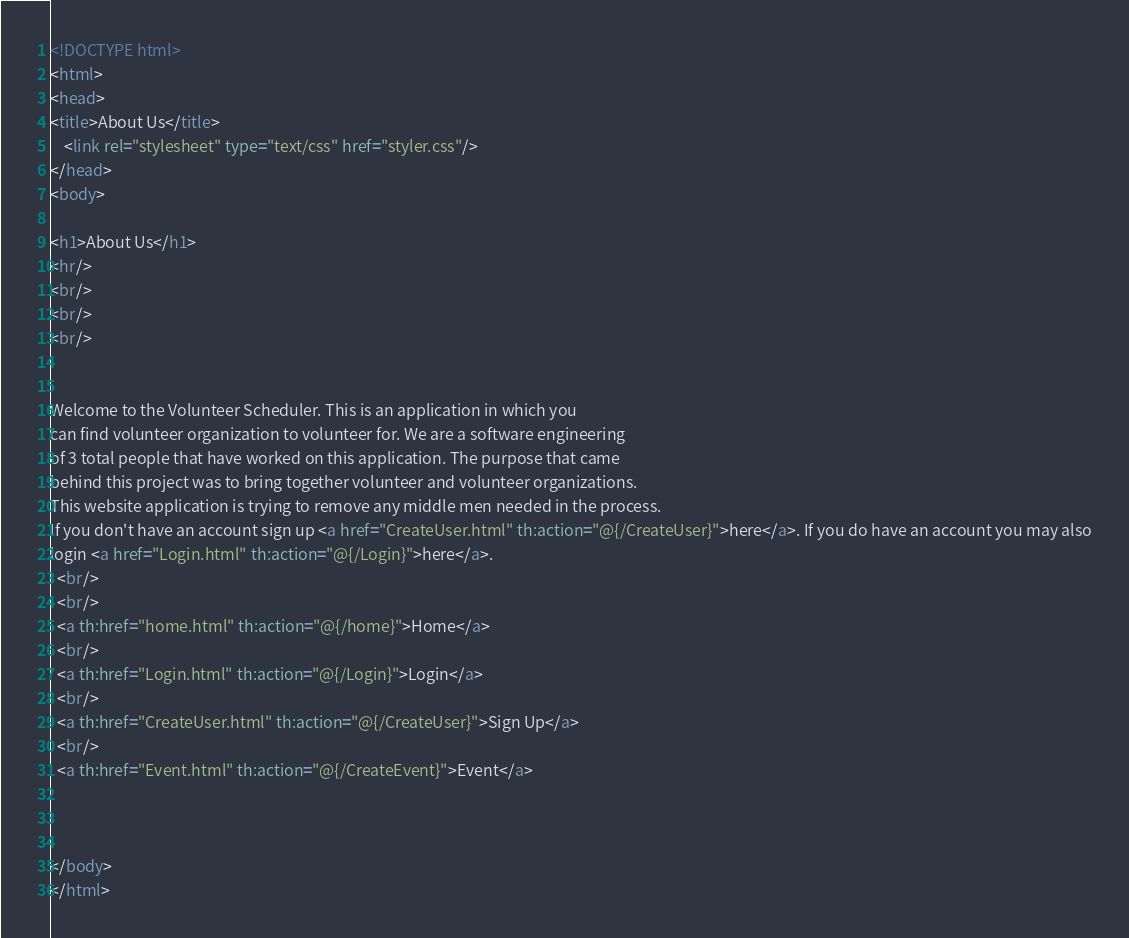Convert code to text. <code><loc_0><loc_0><loc_500><loc_500><_HTML_><!DOCTYPE html>
<html>
<head>
<title>About Us</title>
    <link rel="stylesheet" type="text/css" href="styler.css"/>
</head>
<body>

<h1>About Us</h1>
<hr/>
<br/>
<br/>
<br/>


Welcome to the Volunteer Scheduler. This is an application in which you
can find volunteer organization to volunteer for. We are a software engineering
of 3 total people that have worked on this application. The purpose that came
behind this project was to bring together volunteer and volunteer organizations.
This website application is trying to remove any middle men needed in the process.
If you don't have an account sign up <a href="CreateUser.html" th:action="@{/CreateUser}">here</a>. If you do have an account you may also
login <a href="Login.html" th:action="@{/Login}">here</a>.
  <br/>
  <br/>
  <a th:href="home.html" th:action="@{/home}">Home</a>
  <br/>
  <a th:href="Login.html" th:action="@{/Login}">Login</a>
  <br/>
  <a th:href="CreateUser.html" th:action="@{/CreateUser}">Sign Up</a>
  <br/>
  <a th:href="Event.html" th:action="@{/CreateEvent}">Event</a>



</body>
</html>
</code> 